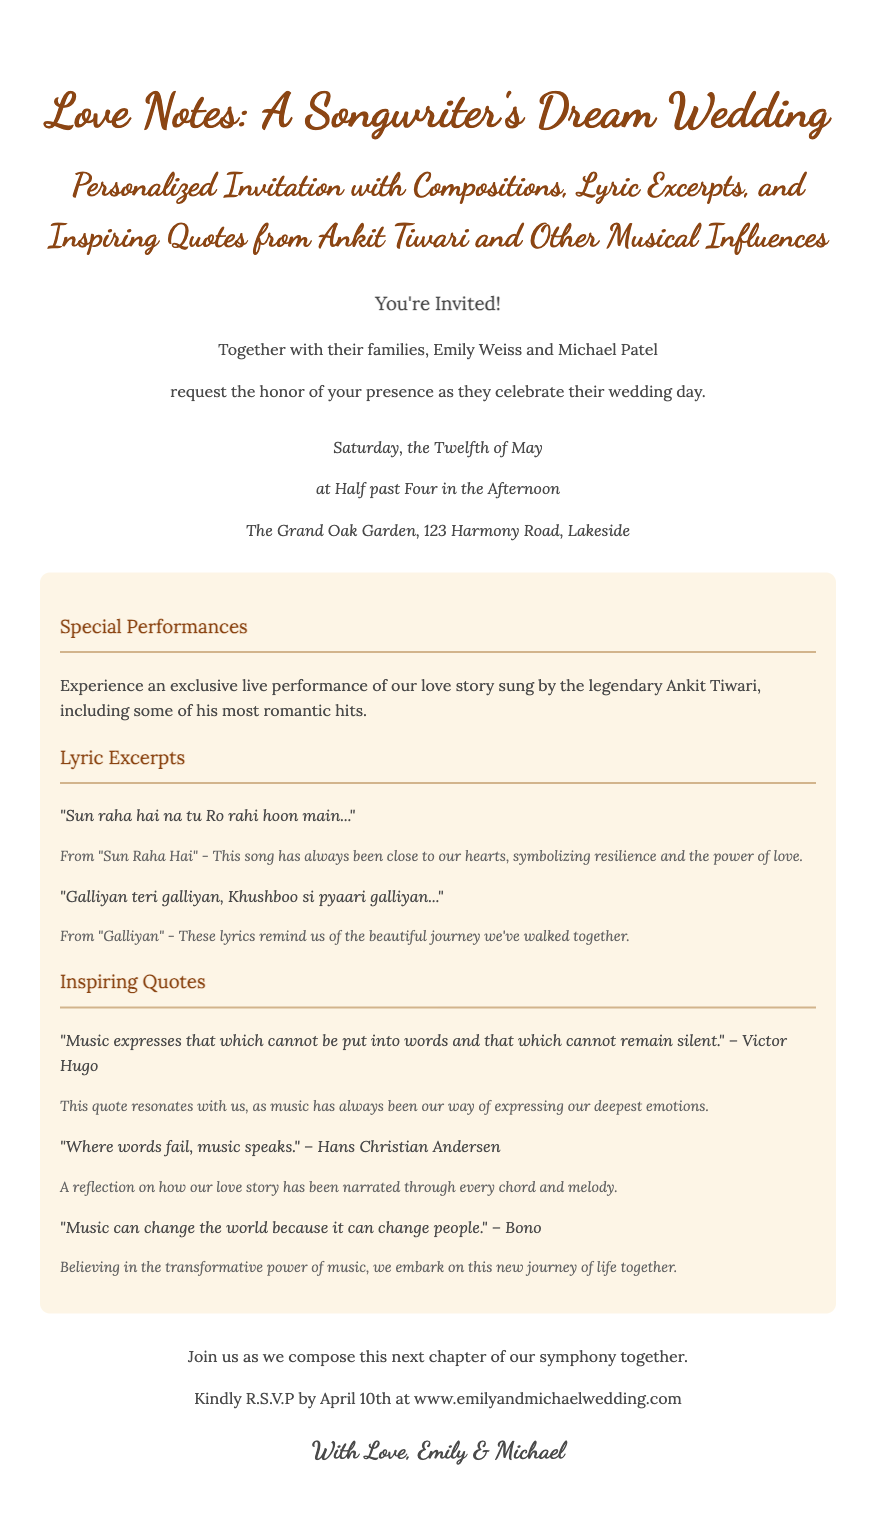What are the names of the couple? The invitation specifies the names Emily Weiss and Michael Patel.
Answer: Emily Weiss and Michael Patel What date is the wedding scheduled for? The invitation clearly states the wedding date as Saturday, the Twelfth of May.
Answer: Twelfth of May What time will the ceremony begin? The details section indicates that the wedding will take place at Half past Four in the Afternoon.
Answer: Half past Four in the Afternoon Who will perform at the wedding? The highlights mention an exclusive live performance by the legendary Ankit Tiwari.
Answer: Ankit Tiwari What thematic element is highlighted in the lyric excerpts? The lyric excerpts chosen convey themes of resilience, love, and beautiful memories.
Answer: Resilience, love, beautiful memories What is the purpose of the quotes included in the invitation? The quotes underscore the significance of music in expressing emotions and the transformative power of love.
Answer: Significance of music in expressing emotions When is the R.S.V.P deadline? The invitation explicitly specifies that the R.S.V.P deadline is April 10th.
Answer: April 10th Where can guests RSVP? The invitation provides a website for R.S.V.P, which is www.emilyandmichaelwedding.com.
Answer: www.emilyandmichaelwedding.com 